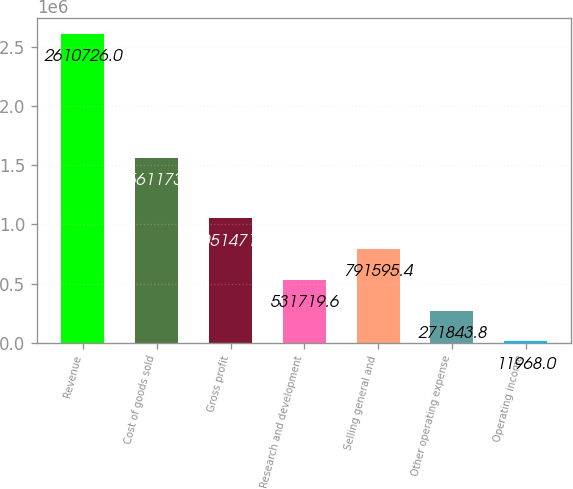<chart> <loc_0><loc_0><loc_500><loc_500><bar_chart><fcel>Revenue<fcel>Cost of goods sold<fcel>Gross profit<fcel>Research and development<fcel>Selling general and<fcel>Other operating expense<fcel>Operating income<nl><fcel>2.61073e+06<fcel>1.56117e+06<fcel>1.05147e+06<fcel>531720<fcel>791595<fcel>271844<fcel>11968<nl></chart> 